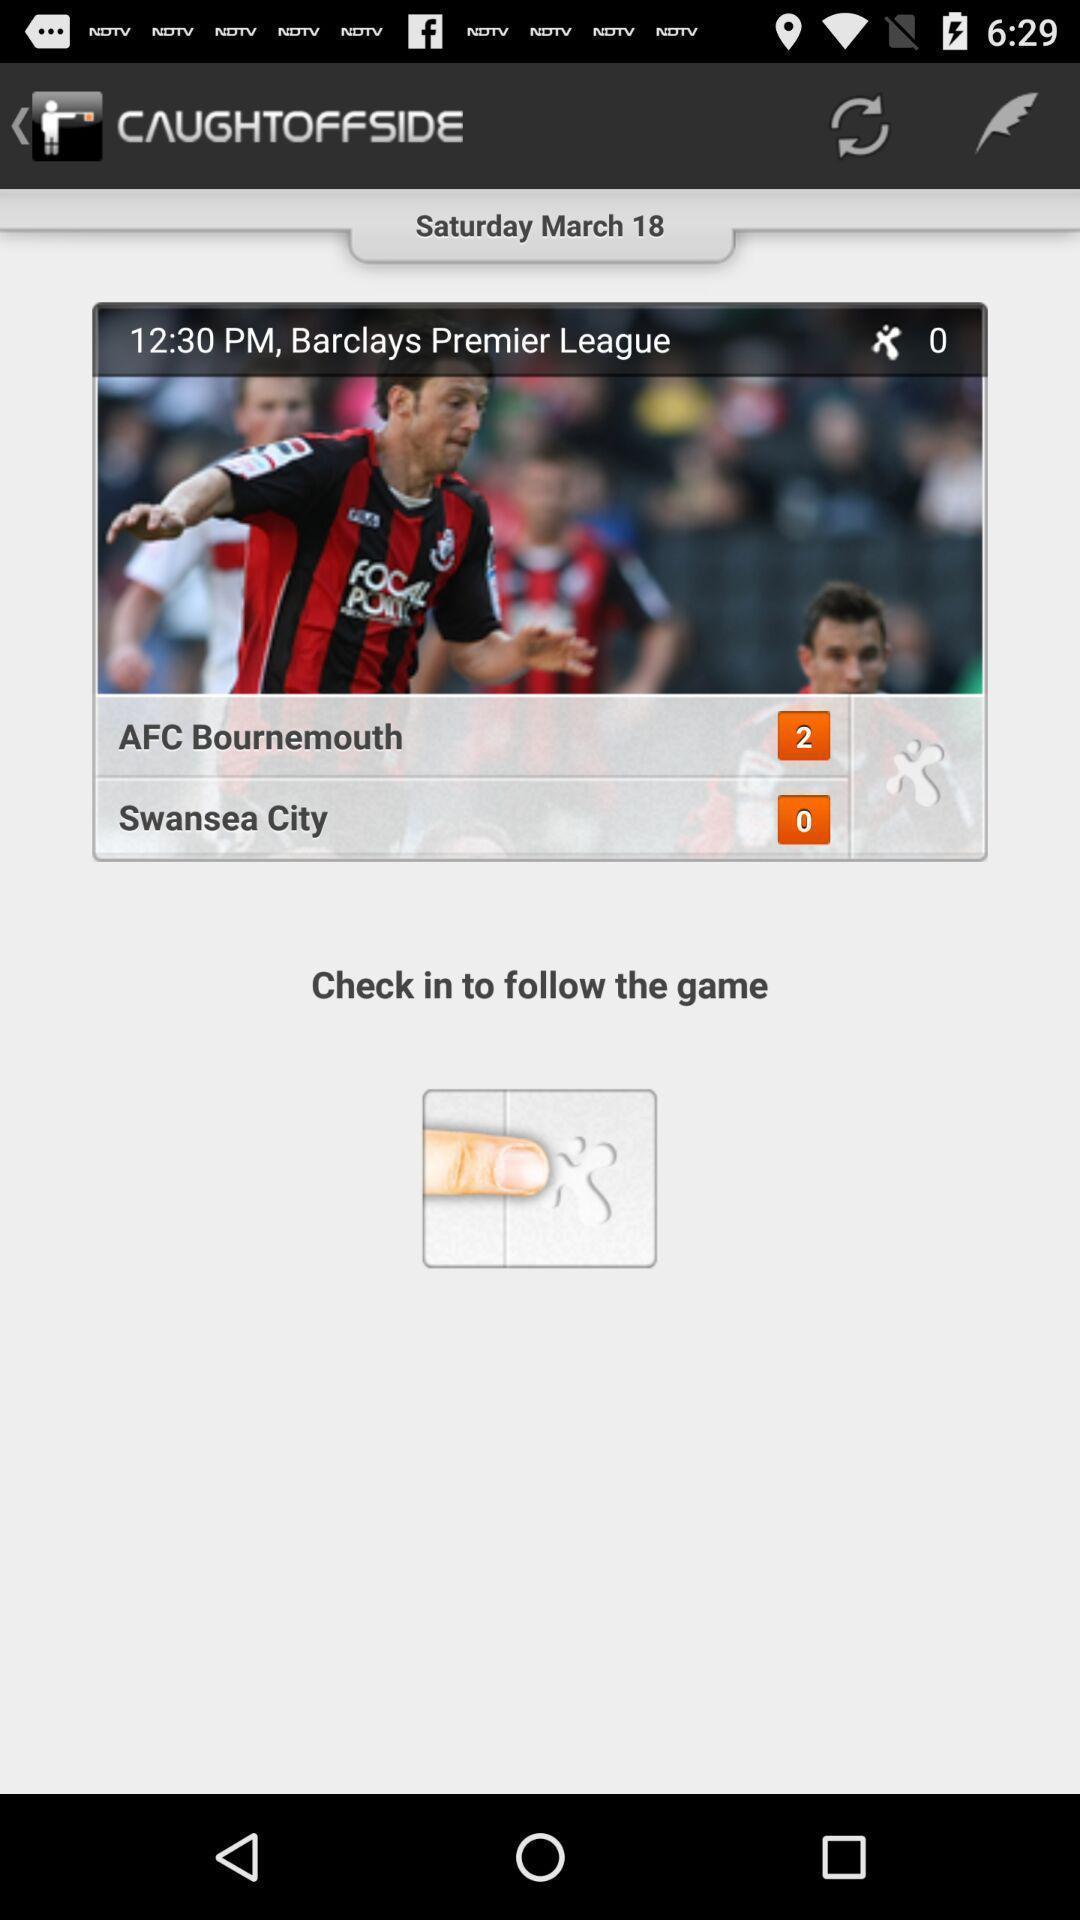Describe the content in this image. Screen displaying contents in football sport application. 